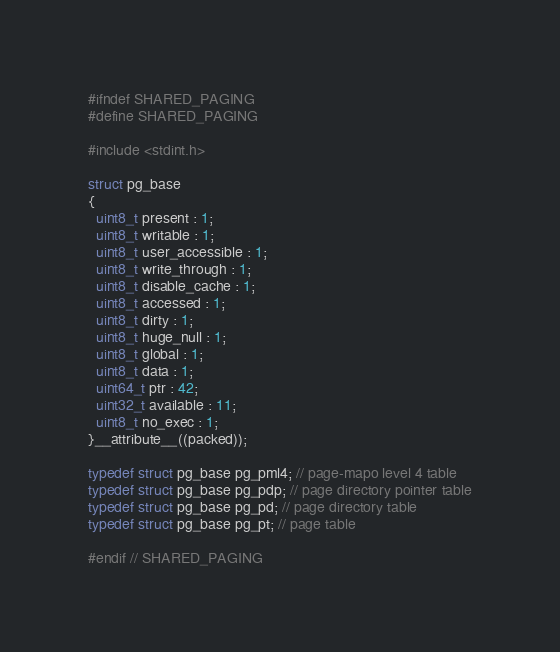Convert code to text. <code><loc_0><loc_0><loc_500><loc_500><_C_>#ifndef SHARED_PAGING
#define SHARED_PAGING

#include <stdint.h>

struct pg_base
{
  uint8_t present : 1;
  uint8_t writable : 1;
  uint8_t user_accessible : 1;
  uint8_t write_through : 1;
  uint8_t disable_cache : 1;
  uint8_t accessed : 1;
  uint8_t dirty : 1;
  uint8_t huge_null : 1;
  uint8_t global : 1;
  uint8_t data : 1;
  uint64_t ptr : 42;
  uint32_t available : 11;
  uint8_t no_exec : 1;
}__attribute__((packed));

typedef struct pg_base pg_pml4; // page-mapo level 4 table
typedef struct pg_base pg_pdp; // page directory pointer table
typedef struct pg_base pg_pd; // page directory table
typedef struct pg_base pg_pt; // page table

#endif // SHARED_PAGING
</code> 